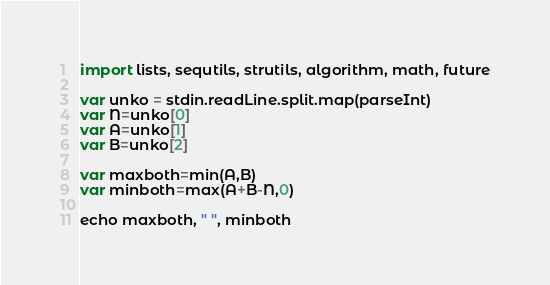<code> <loc_0><loc_0><loc_500><loc_500><_Nim_>import lists, sequtils, strutils, algorithm, math, future

var unko = stdin.readLine.split.map(parseInt)
var N=unko[0]
var A=unko[1]
var B=unko[2]

var maxboth=min(A,B)
var minboth=max(A+B-N,0)

echo maxboth, " ", minboth</code> 